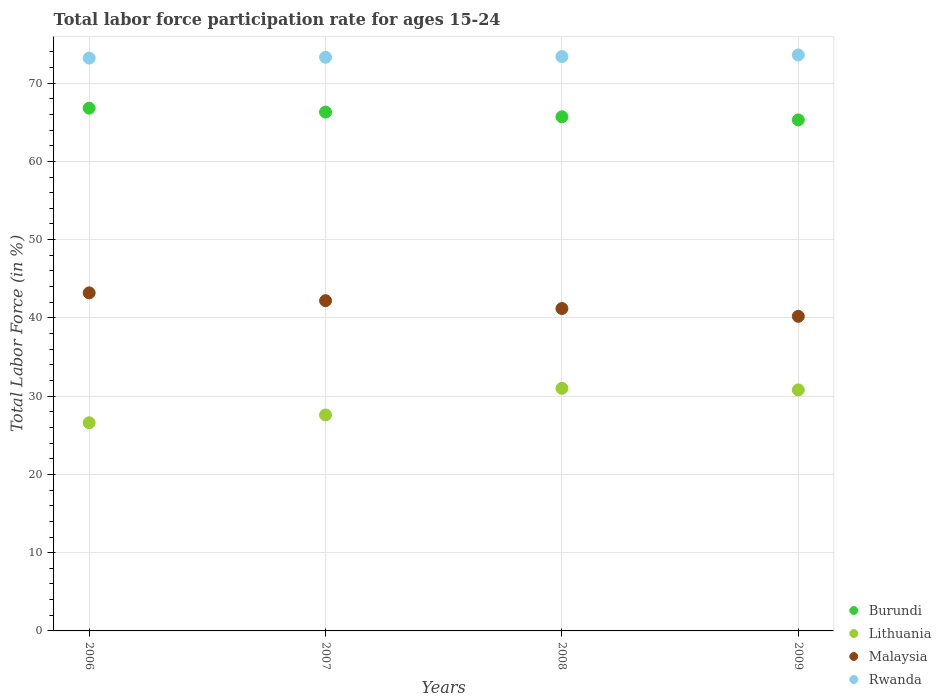What is the labor force participation rate in Lithuania in 2007?
Keep it short and to the point. 27.6. Across all years, what is the maximum labor force participation rate in Lithuania?
Provide a succinct answer. 31. Across all years, what is the minimum labor force participation rate in Malaysia?
Keep it short and to the point. 40.2. What is the total labor force participation rate in Lithuania in the graph?
Make the answer very short. 116. What is the difference between the labor force participation rate in Rwanda in 2006 and that in 2007?
Your answer should be compact. -0.1. What is the difference between the labor force participation rate in Lithuania in 2007 and the labor force participation rate in Rwanda in 2009?
Give a very brief answer. -46. What is the average labor force participation rate in Malaysia per year?
Your answer should be compact. 41.7. In the year 2006, what is the difference between the labor force participation rate in Lithuania and labor force participation rate in Burundi?
Your answer should be compact. -40.2. What is the ratio of the labor force participation rate in Malaysia in 2007 to that in 2008?
Offer a terse response. 1.02. Is the difference between the labor force participation rate in Lithuania in 2007 and 2008 greater than the difference between the labor force participation rate in Burundi in 2007 and 2008?
Ensure brevity in your answer.  No. What is the difference between the highest and the lowest labor force participation rate in Rwanda?
Give a very brief answer. 0.4. Is the sum of the labor force participation rate in Burundi in 2007 and 2009 greater than the maximum labor force participation rate in Rwanda across all years?
Offer a very short reply. Yes. Is it the case that in every year, the sum of the labor force participation rate in Malaysia and labor force participation rate in Rwanda  is greater than the sum of labor force participation rate in Burundi and labor force participation rate in Lithuania?
Keep it short and to the point. No. Does the labor force participation rate in Malaysia monotonically increase over the years?
Make the answer very short. No. Is the labor force participation rate in Burundi strictly greater than the labor force participation rate in Malaysia over the years?
Your answer should be very brief. Yes. How many dotlines are there?
Ensure brevity in your answer.  4. What is the difference between two consecutive major ticks on the Y-axis?
Give a very brief answer. 10. Are the values on the major ticks of Y-axis written in scientific E-notation?
Give a very brief answer. No. Does the graph contain any zero values?
Give a very brief answer. No. Does the graph contain grids?
Ensure brevity in your answer.  Yes. How many legend labels are there?
Keep it short and to the point. 4. What is the title of the graph?
Provide a succinct answer. Total labor force participation rate for ages 15-24. What is the label or title of the X-axis?
Your answer should be compact. Years. What is the Total Labor Force (in %) in Burundi in 2006?
Provide a succinct answer. 66.8. What is the Total Labor Force (in %) of Lithuania in 2006?
Make the answer very short. 26.6. What is the Total Labor Force (in %) in Malaysia in 2006?
Provide a succinct answer. 43.2. What is the Total Labor Force (in %) in Rwanda in 2006?
Your answer should be very brief. 73.2. What is the Total Labor Force (in %) in Burundi in 2007?
Make the answer very short. 66.3. What is the Total Labor Force (in %) in Lithuania in 2007?
Your answer should be very brief. 27.6. What is the Total Labor Force (in %) in Malaysia in 2007?
Give a very brief answer. 42.2. What is the Total Labor Force (in %) in Rwanda in 2007?
Give a very brief answer. 73.3. What is the Total Labor Force (in %) in Burundi in 2008?
Make the answer very short. 65.7. What is the Total Labor Force (in %) in Malaysia in 2008?
Make the answer very short. 41.2. What is the Total Labor Force (in %) of Rwanda in 2008?
Offer a terse response. 73.4. What is the Total Labor Force (in %) in Burundi in 2009?
Provide a succinct answer. 65.3. What is the Total Labor Force (in %) of Lithuania in 2009?
Your answer should be very brief. 30.8. What is the Total Labor Force (in %) in Malaysia in 2009?
Your response must be concise. 40.2. What is the Total Labor Force (in %) in Rwanda in 2009?
Keep it short and to the point. 73.6. Across all years, what is the maximum Total Labor Force (in %) in Burundi?
Make the answer very short. 66.8. Across all years, what is the maximum Total Labor Force (in %) in Malaysia?
Give a very brief answer. 43.2. Across all years, what is the maximum Total Labor Force (in %) of Rwanda?
Offer a very short reply. 73.6. Across all years, what is the minimum Total Labor Force (in %) in Burundi?
Keep it short and to the point. 65.3. Across all years, what is the minimum Total Labor Force (in %) of Lithuania?
Provide a succinct answer. 26.6. Across all years, what is the minimum Total Labor Force (in %) of Malaysia?
Your answer should be very brief. 40.2. Across all years, what is the minimum Total Labor Force (in %) of Rwanda?
Provide a short and direct response. 73.2. What is the total Total Labor Force (in %) of Burundi in the graph?
Your answer should be very brief. 264.1. What is the total Total Labor Force (in %) of Lithuania in the graph?
Ensure brevity in your answer.  116. What is the total Total Labor Force (in %) of Malaysia in the graph?
Give a very brief answer. 166.8. What is the total Total Labor Force (in %) of Rwanda in the graph?
Keep it short and to the point. 293.5. What is the difference between the Total Labor Force (in %) of Lithuania in 2006 and that in 2007?
Make the answer very short. -1. What is the difference between the Total Labor Force (in %) of Burundi in 2006 and that in 2008?
Keep it short and to the point. 1.1. What is the difference between the Total Labor Force (in %) in Burundi in 2006 and that in 2009?
Offer a terse response. 1.5. What is the difference between the Total Labor Force (in %) of Lithuania in 2006 and that in 2009?
Ensure brevity in your answer.  -4.2. What is the difference between the Total Labor Force (in %) of Burundi in 2007 and that in 2008?
Provide a short and direct response. 0.6. What is the difference between the Total Labor Force (in %) of Rwanda in 2007 and that in 2008?
Provide a short and direct response. -0.1. What is the difference between the Total Labor Force (in %) of Burundi in 2007 and that in 2009?
Make the answer very short. 1. What is the difference between the Total Labor Force (in %) of Rwanda in 2007 and that in 2009?
Offer a terse response. -0.3. What is the difference between the Total Labor Force (in %) in Burundi in 2006 and the Total Labor Force (in %) in Lithuania in 2007?
Offer a very short reply. 39.2. What is the difference between the Total Labor Force (in %) in Burundi in 2006 and the Total Labor Force (in %) in Malaysia in 2007?
Your response must be concise. 24.6. What is the difference between the Total Labor Force (in %) of Lithuania in 2006 and the Total Labor Force (in %) of Malaysia in 2007?
Give a very brief answer. -15.6. What is the difference between the Total Labor Force (in %) in Lithuania in 2006 and the Total Labor Force (in %) in Rwanda in 2007?
Your answer should be very brief. -46.7. What is the difference between the Total Labor Force (in %) in Malaysia in 2006 and the Total Labor Force (in %) in Rwanda in 2007?
Offer a very short reply. -30.1. What is the difference between the Total Labor Force (in %) of Burundi in 2006 and the Total Labor Force (in %) of Lithuania in 2008?
Provide a succinct answer. 35.8. What is the difference between the Total Labor Force (in %) in Burundi in 2006 and the Total Labor Force (in %) in Malaysia in 2008?
Provide a succinct answer. 25.6. What is the difference between the Total Labor Force (in %) in Lithuania in 2006 and the Total Labor Force (in %) in Malaysia in 2008?
Offer a terse response. -14.6. What is the difference between the Total Labor Force (in %) of Lithuania in 2006 and the Total Labor Force (in %) of Rwanda in 2008?
Ensure brevity in your answer.  -46.8. What is the difference between the Total Labor Force (in %) of Malaysia in 2006 and the Total Labor Force (in %) of Rwanda in 2008?
Your response must be concise. -30.2. What is the difference between the Total Labor Force (in %) of Burundi in 2006 and the Total Labor Force (in %) of Lithuania in 2009?
Give a very brief answer. 36. What is the difference between the Total Labor Force (in %) of Burundi in 2006 and the Total Labor Force (in %) of Malaysia in 2009?
Offer a terse response. 26.6. What is the difference between the Total Labor Force (in %) in Lithuania in 2006 and the Total Labor Force (in %) in Rwanda in 2009?
Offer a very short reply. -47. What is the difference between the Total Labor Force (in %) of Malaysia in 2006 and the Total Labor Force (in %) of Rwanda in 2009?
Provide a short and direct response. -30.4. What is the difference between the Total Labor Force (in %) of Burundi in 2007 and the Total Labor Force (in %) of Lithuania in 2008?
Ensure brevity in your answer.  35.3. What is the difference between the Total Labor Force (in %) of Burundi in 2007 and the Total Labor Force (in %) of Malaysia in 2008?
Provide a short and direct response. 25.1. What is the difference between the Total Labor Force (in %) of Lithuania in 2007 and the Total Labor Force (in %) of Rwanda in 2008?
Ensure brevity in your answer.  -45.8. What is the difference between the Total Labor Force (in %) in Malaysia in 2007 and the Total Labor Force (in %) in Rwanda in 2008?
Your answer should be very brief. -31.2. What is the difference between the Total Labor Force (in %) in Burundi in 2007 and the Total Labor Force (in %) in Lithuania in 2009?
Offer a terse response. 35.5. What is the difference between the Total Labor Force (in %) of Burundi in 2007 and the Total Labor Force (in %) of Malaysia in 2009?
Your answer should be compact. 26.1. What is the difference between the Total Labor Force (in %) in Lithuania in 2007 and the Total Labor Force (in %) in Malaysia in 2009?
Your response must be concise. -12.6. What is the difference between the Total Labor Force (in %) of Lithuania in 2007 and the Total Labor Force (in %) of Rwanda in 2009?
Offer a very short reply. -46. What is the difference between the Total Labor Force (in %) of Malaysia in 2007 and the Total Labor Force (in %) of Rwanda in 2009?
Make the answer very short. -31.4. What is the difference between the Total Labor Force (in %) of Burundi in 2008 and the Total Labor Force (in %) of Lithuania in 2009?
Your response must be concise. 34.9. What is the difference between the Total Labor Force (in %) of Burundi in 2008 and the Total Labor Force (in %) of Rwanda in 2009?
Your answer should be very brief. -7.9. What is the difference between the Total Labor Force (in %) of Lithuania in 2008 and the Total Labor Force (in %) of Rwanda in 2009?
Give a very brief answer. -42.6. What is the difference between the Total Labor Force (in %) in Malaysia in 2008 and the Total Labor Force (in %) in Rwanda in 2009?
Offer a very short reply. -32.4. What is the average Total Labor Force (in %) in Burundi per year?
Make the answer very short. 66.03. What is the average Total Labor Force (in %) in Lithuania per year?
Your response must be concise. 29. What is the average Total Labor Force (in %) of Malaysia per year?
Your response must be concise. 41.7. What is the average Total Labor Force (in %) in Rwanda per year?
Ensure brevity in your answer.  73.38. In the year 2006, what is the difference between the Total Labor Force (in %) of Burundi and Total Labor Force (in %) of Lithuania?
Offer a very short reply. 40.2. In the year 2006, what is the difference between the Total Labor Force (in %) of Burundi and Total Labor Force (in %) of Malaysia?
Provide a succinct answer. 23.6. In the year 2006, what is the difference between the Total Labor Force (in %) in Lithuania and Total Labor Force (in %) in Malaysia?
Your response must be concise. -16.6. In the year 2006, what is the difference between the Total Labor Force (in %) of Lithuania and Total Labor Force (in %) of Rwanda?
Make the answer very short. -46.6. In the year 2006, what is the difference between the Total Labor Force (in %) of Malaysia and Total Labor Force (in %) of Rwanda?
Your answer should be very brief. -30. In the year 2007, what is the difference between the Total Labor Force (in %) in Burundi and Total Labor Force (in %) in Lithuania?
Your answer should be compact. 38.7. In the year 2007, what is the difference between the Total Labor Force (in %) in Burundi and Total Labor Force (in %) in Malaysia?
Your answer should be very brief. 24.1. In the year 2007, what is the difference between the Total Labor Force (in %) of Burundi and Total Labor Force (in %) of Rwanda?
Your response must be concise. -7. In the year 2007, what is the difference between the Total Labor Force (in %) of Lithuania and Total Labor Force (in %) of Malaysia?
Provide a succinct answer. -14.6. In the year 2007, what is the difference between the Total Labor Force (in %) in Lithuania and Total Labor Force (in %) in Rwanda?
Give a very brief answer. -45.7. In the year 2007, what is the difference between the Total Labor Force (in %) in Malaysia and Total Labor Force (in %) in Rwanda?
Provide a short and direct response. -31.1. In the year 2008, what is the difference between the Total Labor Force (in %) of Burundi and Total Labor Force (in %) of Lithuania?
Give a very brief answer. 34.7. In the year 2008, what is the difference between the Total Labor Force (in %) in Burundi and Total Labor Force (in %) in Malaysia?
Offer a very short reply. 24.5. In the year 2008, what is the difference between the Total Labor Force (in %) of Burundi and Total Labor Force (in %) of Rwanda?
Your answer should be compact. -7.7. In the year 2008, what is the difference between the Total Labor Force (in %) of Lithuania and Total Labor Force (in %) of Rwanda?
Keep it short and to the point. -42.4. In the year 2008, what is the difference between the Total Labor Force (in %) in Malaysia and Total Labor Force (in %) in Rwanda?
Your answer should be compact. -32.2. In the year 2009, what is the difference between the Total Labor Force (in %) of Burundi and Total Labor Force (in %) of Lithuania?
Provide a succinct answer. 34.5. In the year 2009, what is the difference between the Total Labor Force (in %) in Burundi and Total Labor Force (in %) in Malaysia?
Your answer should be very brief. 25.1. In the year 2009, what is the difference between the Total Labor Force (in %) in Burundi and Total Labor Force (in %) in Rwanda?
Make the answer very short. -8.3. In the year 2009, what is the difference between the Total Labor Force (in %) of Lithuania and Total Labor Force (in %) of Malaysia?
Your answer should be compact. -9.4. In the year 2009, what is the difference between the Total Labor Force (in %) in Lithuania and Total Labor Force (in %) in Rwanda?
Provide a succinct answer. -42.8. In the year 2009, what is the difference between the Total Labor Force (in %) in Malaysia and Total Labor Force (in %) in Rwanda?
Keep it short and to the point. -33.4. What is the ratio of the Total Labor Force (in %) in Burundi in 2006 to that in 2007?
Make the answer very short. 1.01. What is the ratio of the Total Labor Force (in %) of Lithuania in 2006 to that in 2007?
Your answer should be very brief. 0.96. What is the ratio of the Total Labor Force (in %) of Malaysia in 2006 to that in 2007?
Ensure brevity in your answer.  1.02. What is the ratio of the Total Labor Force (in %) of Rwanda in 2006 to that in 2007?
Provide a short and direct response. 1. What is the ratio of the Total Labor Force (in %) of Burundi in 2006 to that in 2008?
Your answer should be compact. 1.02. What is the ratio of the Total Labor Force (in %) in Lithuania in 2006 to that in 2008?
Provide a succinct answer. 0.86. What is the ratio of the Total Labor Force (in %) in Malaysia in 2006 to that in 2008?
Offer a terse response. 1.05. What is the ratio of the Total Labor Force (in %) in Rwanda in 2006 to that in 2008?
Provide a short and direct response. 1. What is the ratio of the Total Labor Force (in %) of Lithuania in 2006 to that in 2009?
Offer a terse response. 0.86. What is the ratio of the Total Labor Force (in %) of Malaysia in 2006 to that in 2009?
Your response must be concise. 1.07. What is the ratio of the Total Labor Force (in %) in Burundi in 2007 to that in 2008?
Your answer should be very brief. 1.01. What is the ratio of the Total Labor Force (in %) in Lithuania in 2007 to that in 2008?
Make the answer very short. 0.89. What is the ratio of the Total Labor Force (in %) in Malaysia in 2007 to that in 2008?
Give a very brief answer. 1.02. What is the ratio of the Total Labor Force (in %) in Rwanda in 2007 to that in 2008?
Provide a short and direct response. 1. What is the ratio of the Total Labor Force (in %) of Burundi in 2007 to that in 2009?
Your response must be concise. 1.02. What is the ratio of the Total Labor Force (in %) of Lithuania in 2007 to that in 2009?
Your response must be concise. 0.9. What is the ratio of the Total Labor Force (in %) of Malaysia in 2007 to that in 2009?
Ensure brevity in your answer.  1.05. What is the ratio of the Total Labor Force (in %) of Malaysia in 2008 to that in 2009?
Make the answer very short. 1.02. What is the ratio of the Total Labor Force (in %) in Rwanda in 2008 to that in 2009?
Offer a terse response. 1. What is the difference between the highest and the second highest Total Labor Force (in %) in Burundi?
Provide a short and direct response. 0.5. What is the difference between the highest and the second highest Total Labor Force (in %) in Malaysia?
Provide a succinct answer. 1. What is the difference between the highest and the lowest Total Labor Force (in %) in Malaysia?
Your answer should be compact. 3. 